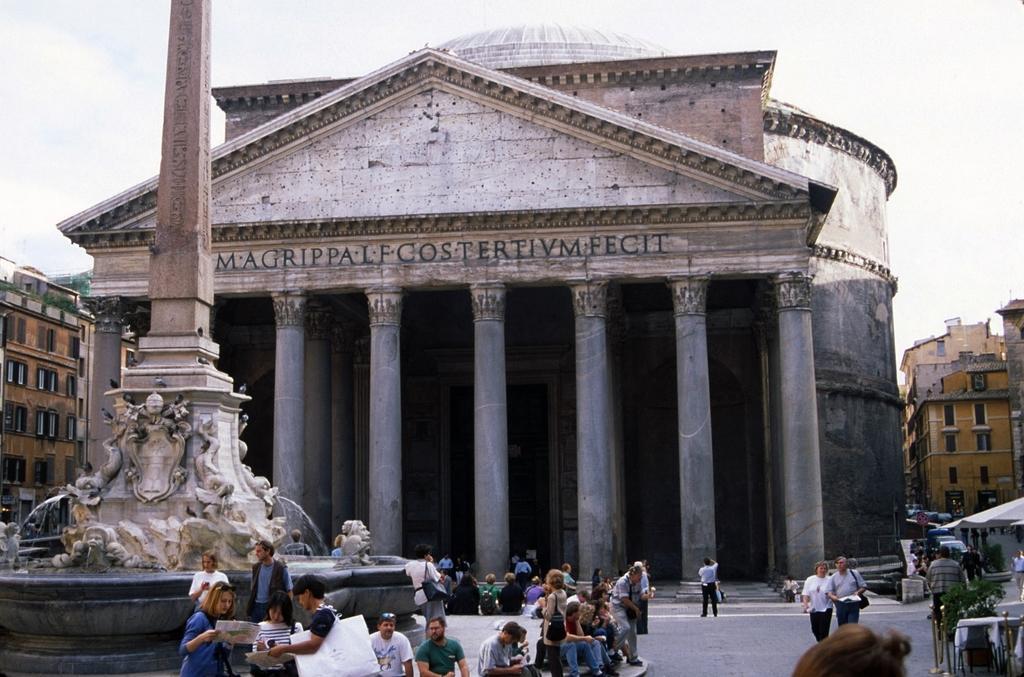In one or two sentences, can you explain what this image depicts? In this picture we can see the buildings, windows, pillars, wall, tent. On the left side of the image we can see a fountain. At the bottom of the image we can see a group of people, road, bicycles. At the top of the image we can see the clouds are present in the sky. 